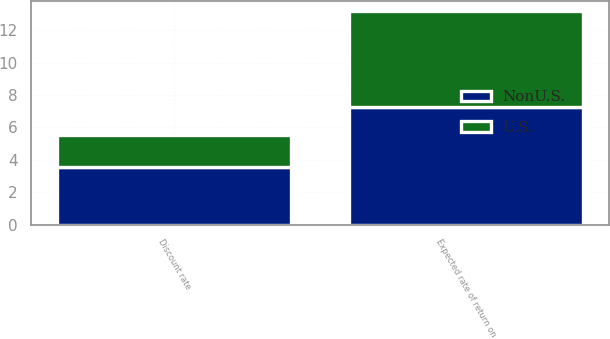Convert chart. <chart><loc_0><loc_0><loc_500><loc_500><stacked_bar_chart><ecel><fcel>Discount rate<fcel>Expected rate of return on<nl><fcel>U.S.<fcel>1.99<fcel>5.9<nl><fcel>NonU.S.<fcel>3.56<fcel>7.25<nl></chart> 